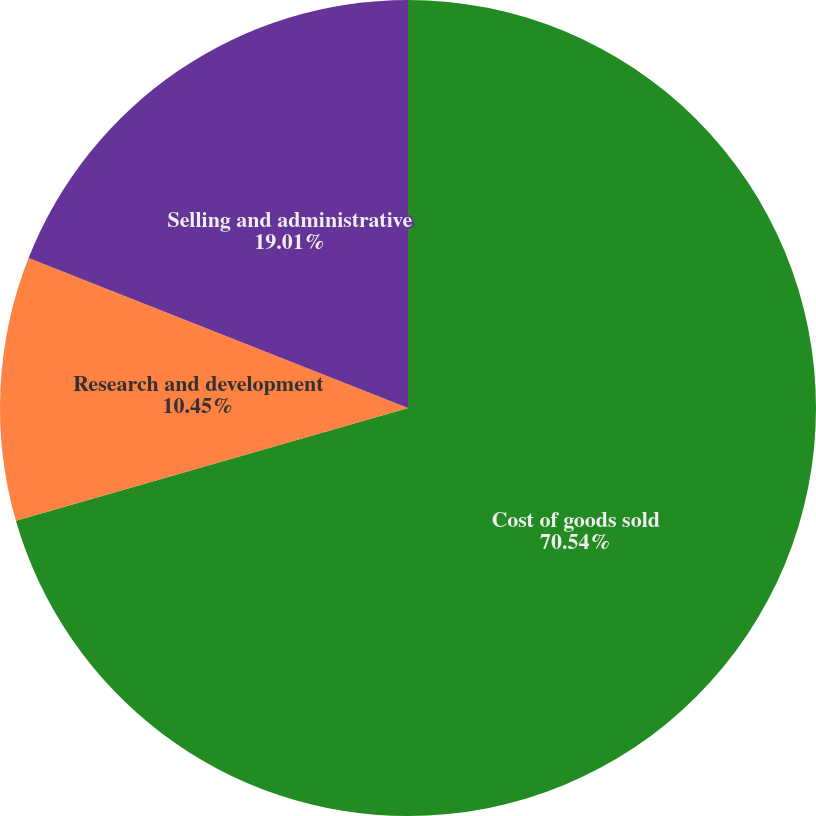Convert chart to OTSL. <chart><loc_0><loc_0><loc_500><loc_500><pie_chart><fcel>Cost of goods sold<fcel>Research and development<fcel>Selling and administrative<nl><fcel>70.54%<fcel>10.45%<fcel>19.01%<nl></chart> 